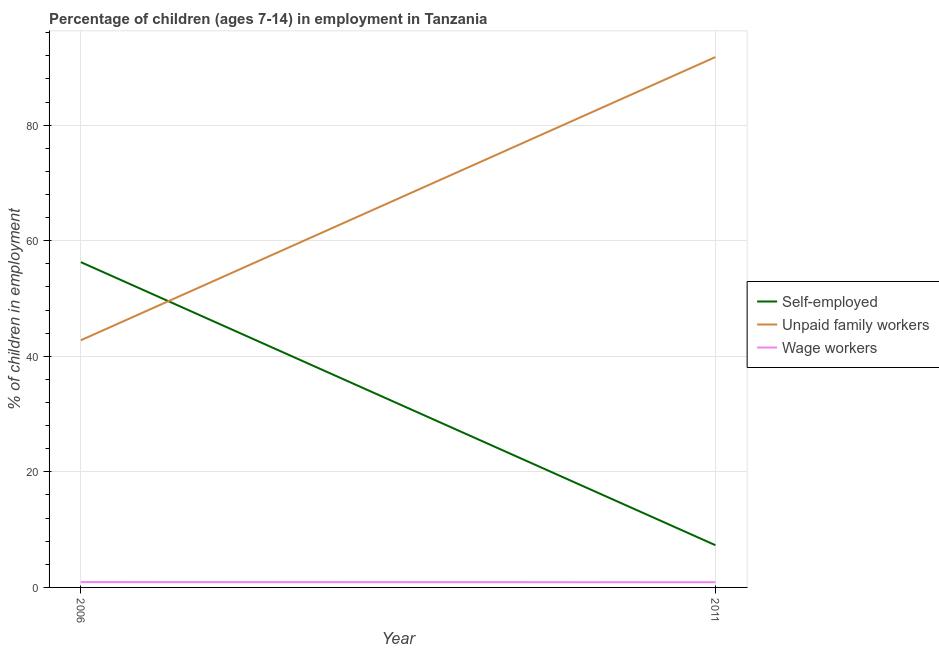Is the number of lines equal to the number of legend labels?
Your answer should be very brief. Yes. What is the percentage of self employed children in 2006?
Offer a terse response. 56.3. Across all years, what is the maximum percentage of self employed children?
Ensure brevity in your answer.  56.3. Across all years, what is the minimum percentage of children employed as unpaid family workers?
Your response must be concise. 42.78. In which year was the percentage of children employed as wage workers maximum?
Give a very brief answer. 2006. In which year was the percentage of self employed children minimum?
Make the answer very short. 2011. What is the total percentage of self employed children in the graph?
Keep it short and to the point. 63.61. What is the difference between the percentage of children employed as unpaid family workers in 2006 and that in 2011?
Give a very brief answer. -49.01. What is the difference between the percentage of children employed as wage workers in 2011 and the percentage of self employed children in 2006?
Your response must be concise. -55.4. What is the average percentage of children employed as unpaid family workers per year?
Your answer should be compact. 67.28. In the year 2011, what is the difference between the percentage of children employed as unpaid family workers and percentage of children employed as wage workers?
Keep it short and to the point. 90.89. What is the ratio of the percentage of children employed as unpaid family workers in 2006 to that in 2011?
Your answer should be compact. 0.47. In how many years, is the percentage of children employed as wage workers greater than the average percentage of children employed as wage workers taken over all years?
Your answer should be compact. 1. Does the percentage of self employed children monotonically increase over the years?
Ensure brevity in your answer.  No. How many lines are there?
Ensure brevity in your answer.  3. How many years are there in the graph?
Offer a very short reply. 2. Does the graph contain any zero values?
Your answer should be very brief. No. Does the graph contain grids?
Your answer should be compact. Yes. Where does the legend appear in the graph?
Provide a succinct answer. Center right. How many legend labels are there?
Ensure brevity in your answer.  3. What is the title of the graph?
Offer a terse response. Percentage of children (ages 7-14) in employment in Tanzania. Does "Coal sources" appear as one of the legend labels in the graph?
Your response must be concise. No. What is the label or title of the X-axis?
Offer a very short reply. Year. What is the label or title of the Y-axis?
Provide a short and direct response. % of children in employment. What is the % of children in employment of Self-employed in 2006?
Your response must be concise. 56.3. What is the % of children in employment in Unpaid family workers in 2006?
Offer a very short reply. 42.78. What is the % of children in employment in Wage workers in 2006?
Provide a short and direct response. 0.92. What is the % of children in employment in Self-employed in 2011?
Provide a succinct answer. 7.31. What is the % of children in employment in Unpaid family workers in 2011?
Ensure brevity in your answer.  91.79. What is the % of children in employment of Wage workers in 2011?
Offer a very short reply. 0.9. Across all years, what is the maximum % of children in employment of Self-employed?
Your answer should be very brief. 56.3. Across all years, what is the maximum % of children in employment of Unpaid family workers?
Offer a very short reply. 91.79. Across all years, what is the minimum % of children in employment in Self-employed?
Your answer should be very brief. 7.31. Across all years, what is the minimum % of children in employment in Unpaid family workers?
Provide a short and direct response. 42.78. What is the total % of children in employment in Self-employed in the graph?
Provide a succinct answer. 63.61. What is the total % of children in employment of Unpaid family workers in the graph?
Provide a succinct answer. 134.57. What is the total % of children in employment in Wage workers in the graph?
Ensure brevity in your answer.  1.82. What is the difference between the % of children in employment of Self-employed in 2006 and that in 2011?
Ensure brevity in your answer.  48.99. What is the difference between the % of children in employment in Unpaid family workers in 2006 and that in 2011?
Keep it short and to the point. -49.01. What is the difference between the % of children in employment of Wage workers in 2006 and that in 2011?
Keep it short and to the point. 0.02. What is the difference between the % of children in employment of Self-employed in 2006 and the % of children in employment of Unpaid family workers in 2011?
Provide a succinct answer. -35.49. What is the difference between the % of children in employment in Self-employed in 2006 and the % of children in employment in Wage workers in 2011?
Your response must be concise. 55.4. What is the difference between the % of children in employment of Unpaid family workers in 2006 and the % of children in employment of Wage workers in 2011?
Give a very brief answer. 41.88. What is the average % of children in employment in Self-employed per year?
Keep it short and to the point. 31.8. What is the average % of children in employment in Unpaid family workers per year?
Offer a terse response. 67.28. What is the average % of children in employment of Wage workers per year?
Your response must be concise. 0.91. In the year 2006, what is the difference between the % of children in employment of Self-employed and % of children in employment of Unpaid family workers?
Ensure brevity in your answer.  13.52. In the year 2006, what is the difference between the % of children in employment in Self-employed and % of children in employment in Wage workers?
Make the answer very short. 55.38. In the year 2006, what is the difference between the % of children in employment of Unpaid family workers and % of children in employment of Wage workers?
Keep it short and to the point. 41.86. In the year 2011, what is the difference between the % of children in employment of Self-employed and % of children in employment of Unpaid family workers?
Provide a short and direct response. -84.48. In the year 2011, what is the difference between the % of children in employment of Self-employed and % of children in employment of Wage workers?
Keep it short and to the point. 6.41. In the year 2011, what is the difference between the % of children in employment in Unpaid family workers and % of children in employment in Wage workers?
Your response must be concise. 90.89. What is the ratio of the % of children in employment in Self-employed in 2006 to that in 2011?
Ensure brevity in your answer.  7.7. What is the ratio of the % of children in employment in Unpaid family workers in 2006 to that in 2011?
Your response must be concise. 0.47. What is the ratio of the % of children in employment in Wage workers in 2006 to that in 2011?
Keep it short and to the point. 1.02. What is the difference between the highest and the second highest % of children in employment in Self-employed?
Ensure brevity in your answer.  48.99. What is the difference between the highest and the second highest % of children in employment in Unpaid family workers?
Your answer should be very brief. 49.01. What is the difference between the highest and the second highest % of children in employment of Wage workers?
Keep it short and to the point. 0.02. What is the difference between the highest and the lowest % of children in employment of Self-employed?
Offer a very short reply. 48.99. What is the difference between the highest and the lowest % of children in employment in Unpaid family workers?
Your answer should be compact. 49.01. 